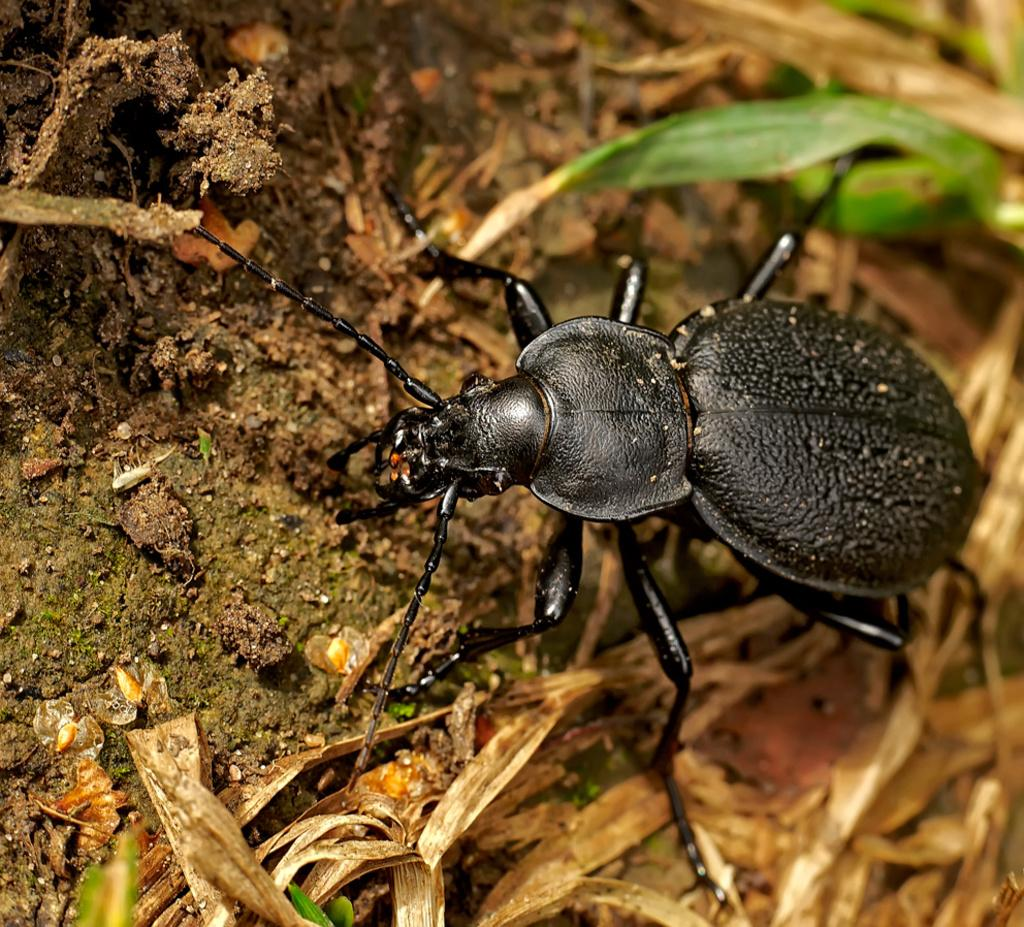What type of insect is in the image? There is a dung beetle in the image. Where is the dung beetle located? The dung beetle is on the ground. What type of vegetation can be seen in the image? There is grass visible in the image. How does the dung beetle contribute to the wealth of the ecosystem in the image? The image does not provide information about the ecosystem or the dung beetle's contribution to it, so we cannot determine its impact on wealth. 